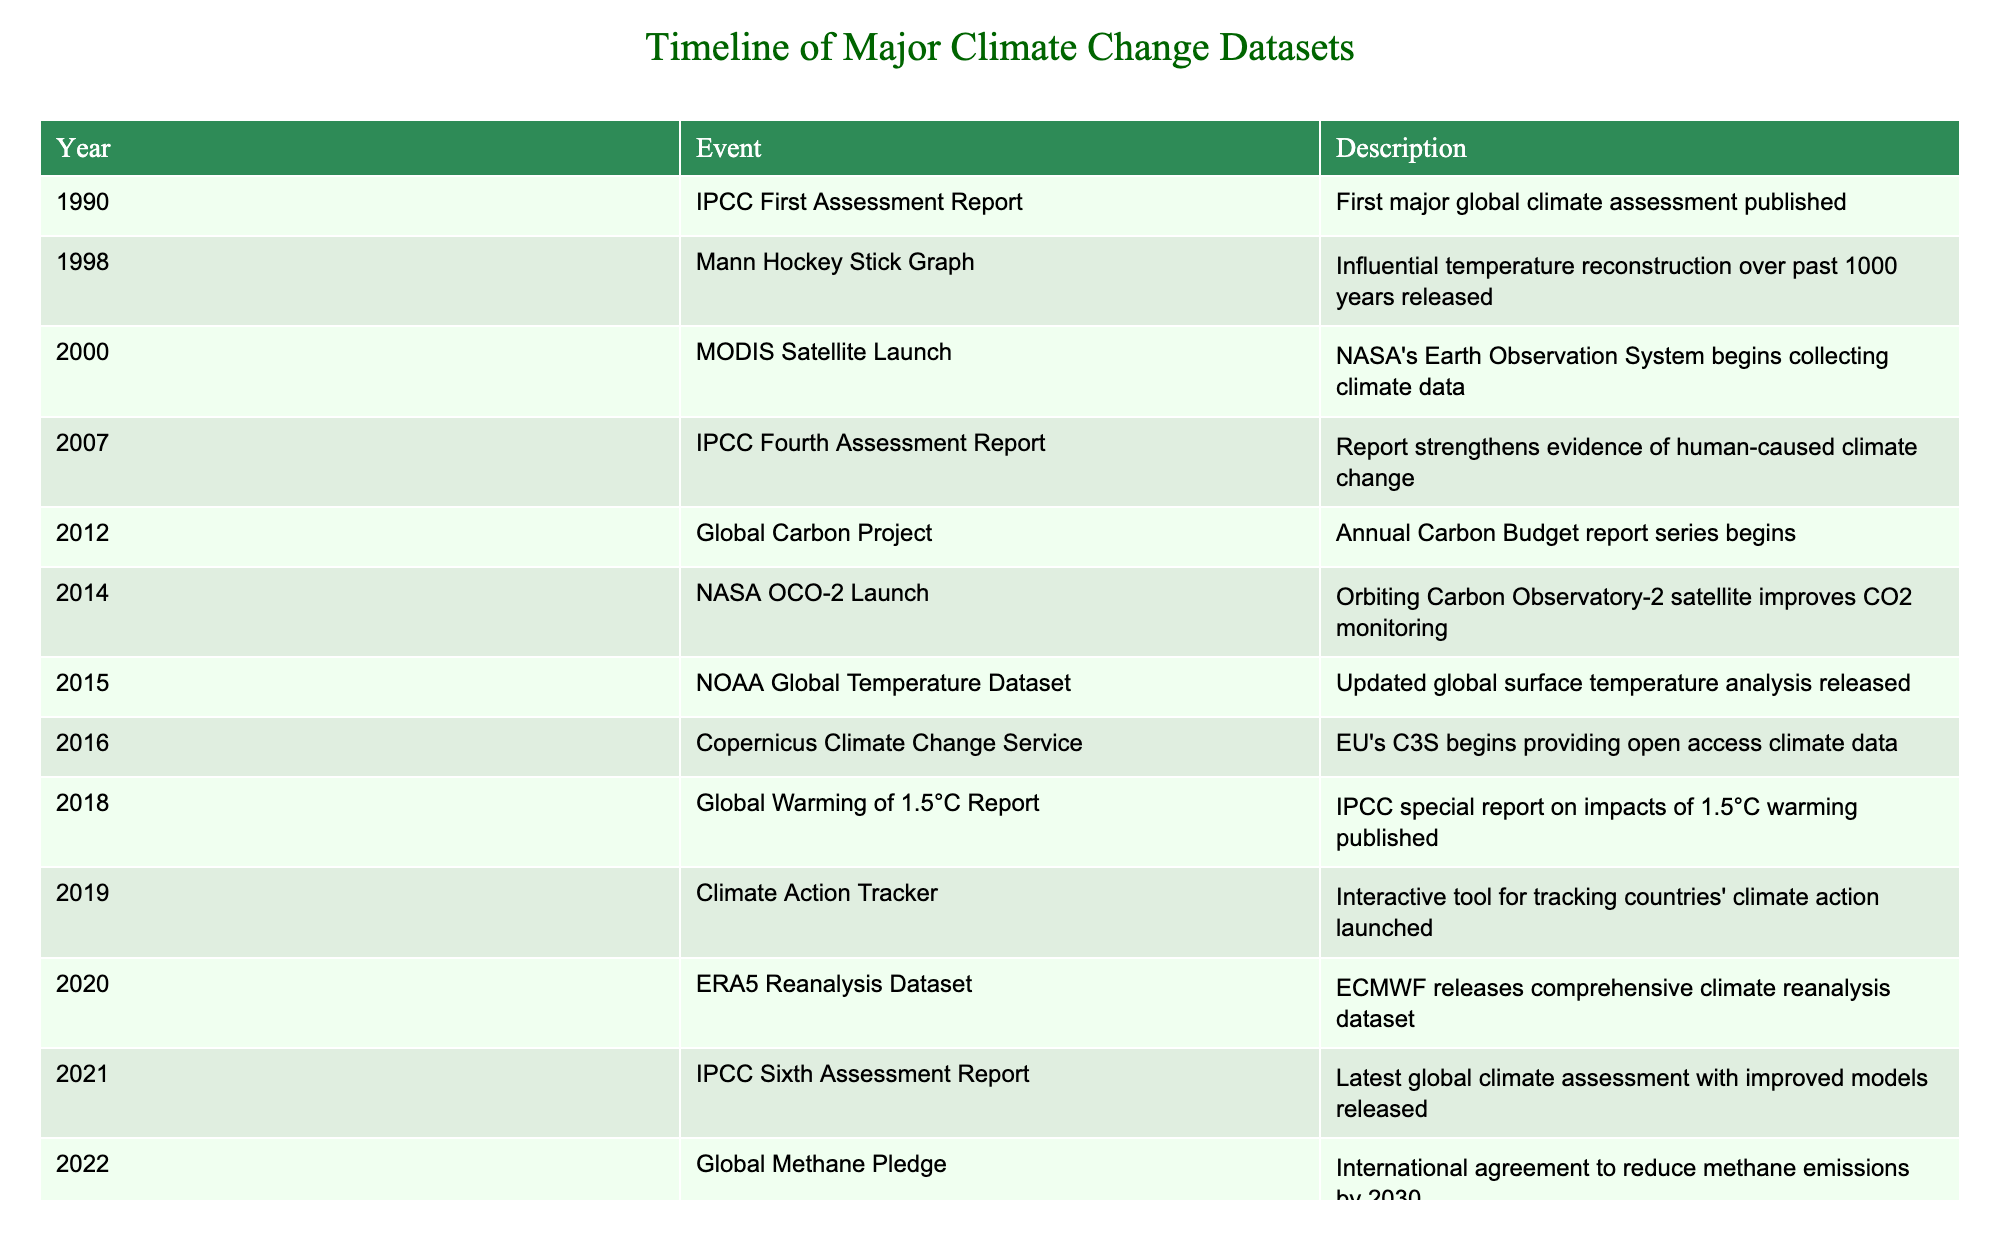What year was the IPCC First Assessment Report released? The table lists events chronologically by year. The first entry states that the IPCC First Assessment Report was released in 1990.
Answer: 1990 What significant event occurred in 2018 about climate change? Referring to the table, the entry for 2018 mentions the publication of the IPCC special report on impacts of 1.5°C warming, titled "Global Warming of 1.5°C Report."
Answer: Global Warming of 1.5°C Report How many years apart were the release of the MODIS Satellite Launch and the NOAA Global Temperature Dataset? From the table, the MODIS Satellite Launch happened in 2000 and the NOAA Global Temperature Dataset was released in 2015. The difference is 15 - 2000 = 15 years.
Answer: 15 years Did the Copernicus Climate Change Service begin providing open access climate data before or after the Global Carbon Project? The Global Carbon Project began in 2012 and the Copernicus Climate Change Service started in 2016. Therefore, the Copernicus service started after the Global Carbon Project.
Answer: After Which event signified the latest major climate assessment according to the table? The table indicates that the latest major climate assessment is the IPCC Sixth Assessment Report, released in 2021.
Answer: IPCC Sixth Assessment Report How many major climate datasets events were recorded between 2000 and 2010? By counting the events listed from the years 2000 to 2010, three events are found: MODIS Satellite Launch (2000), IPCC Fourth Assessment Report (2007), and NOAA Global Temperature Dataset (2015). The final event (NOAA Global Temperature Dataset) is actually beyond the 2010 mark, therefore the count is 2 major events.
Answer: 2 Is the Global Methane Pledge focused on reducing carbon emissions? The entry for the Global Methane Pledge in 2022 describes an agreement to reduce methane emissions by 2030, not carbon emissions. Thus, it specifically targets methane.
Answer: No Between which years were the most major climate datasets published according to the table? Examining the entries closely, the years 1998 through 2000 show consecutive events (Mann Hockey Stick Graph, MODIS Satellite Launch), and there’s another consecutive series from 2014 (NASA OCO-2 Launch) to 2019 (Climate Action Tracker). Therefore, 1998 to 2000 has three consecutive significant entries, indicating it is one of the busiest periods in the timeline.
Answer: 1998 to 2000 